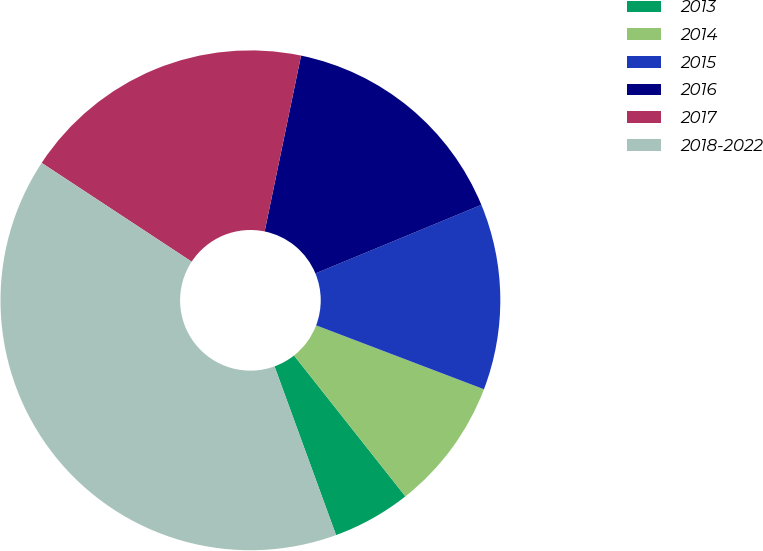Convert chart to OTSL. <chart><loc_0><loc_0><loc_500><loc_500><pie_chart><fcel>2013<fcel>2014<fcel>2015<fcel>2016<fcel>2017<fcel>2018-2022<nl><fcel>5.08%<fcel>8.56%<fcel>12.03%<fcel>15.51%<fcel>18.98%<fcel>39.83%<nl></chart> 